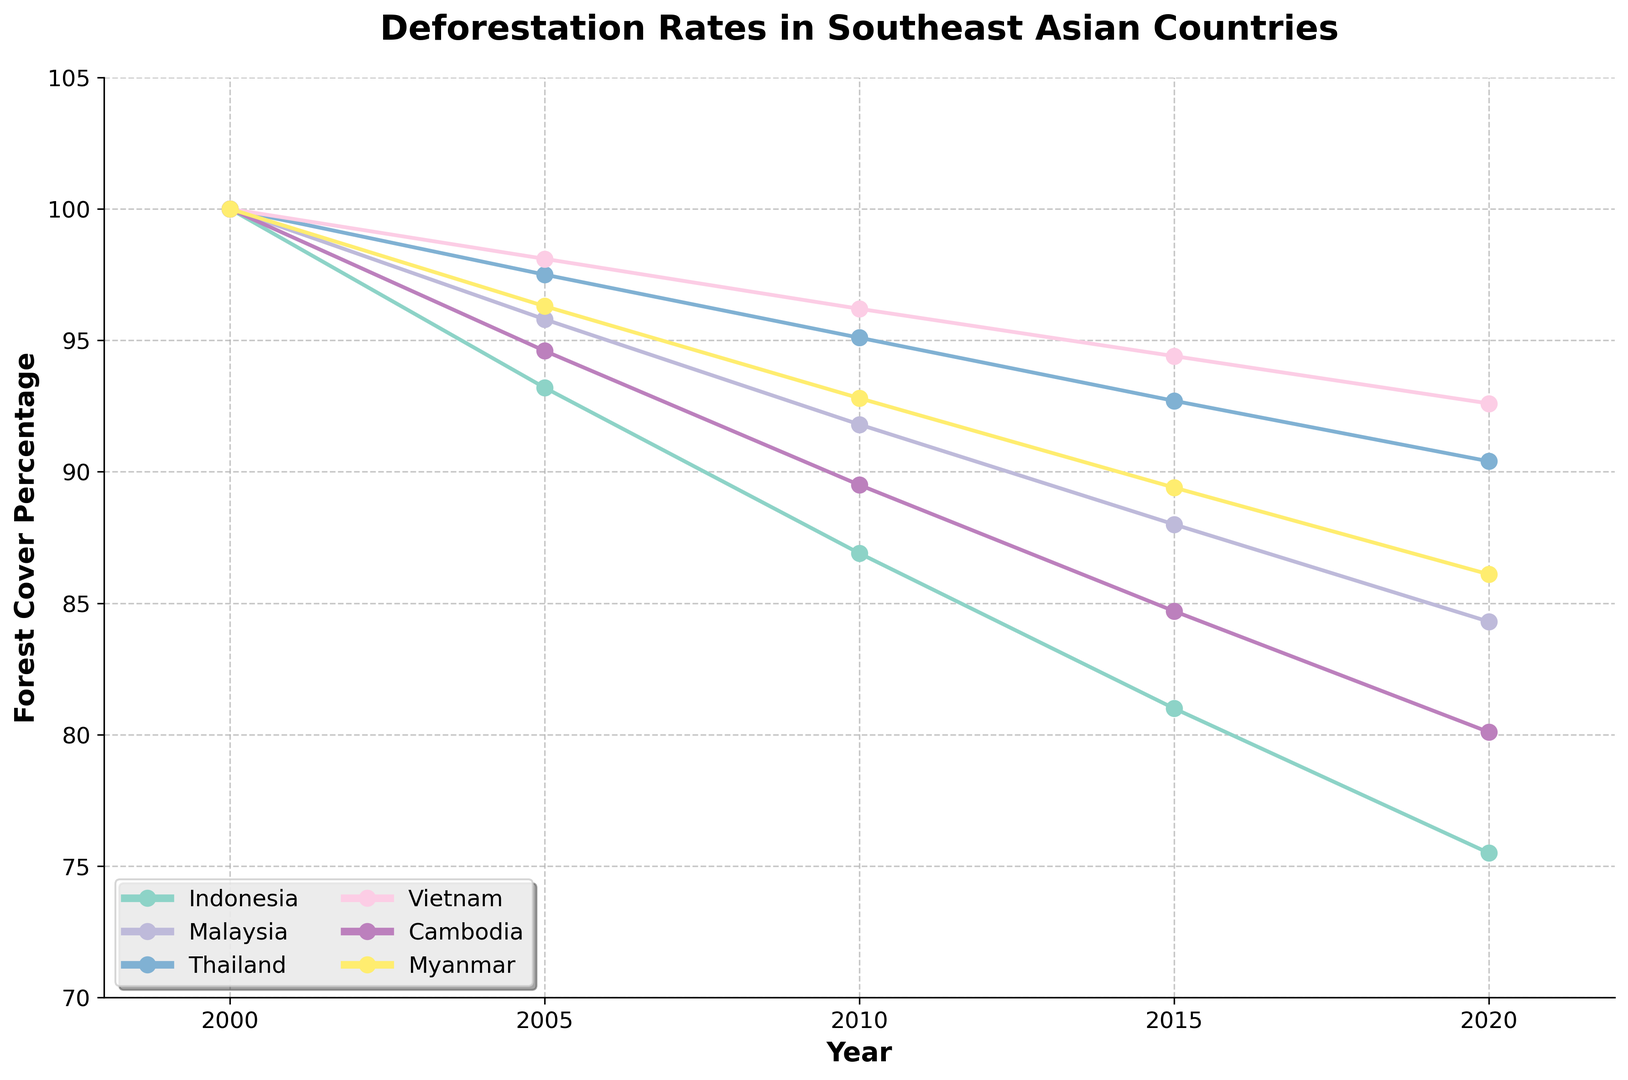What is the overall trend of forest cover percentage in Indonesia from 2000 to 2020? The plot shows a visible decline in the forest cover percentage for Indonesia over the years 2000 to 2020. The percentage starts at 100% in 2000 and decreases to around 75.5% by 2020.
Answer: Declining Which country had the highest forest cover percentage in 2020? By observing the endpoint of each country's line in the plot for the year 2020, Vietnam has the highest forest cover percentage around 92.6%.
Answer: Vietnam Compare the rate of deforestation between Malaysia and Cambodia from 2000 to 2020. Which country experienced a greater reduction in forest cover percentage? For Malaysia, the reduction is from 100% to 84.3%, a decrease of 15.7%. For Cambodia, the reduction is from 100% to 80.1%, a decrease of 19.9%. Cambodia experienced a greater reduction in forest cover percentage.
Answer: Cambodia Calculate the average forest cover percentage for Thailand over the years 2000 to 2020. The values for Thailand are 100%, 97.5%, 95.1%, 92.7%, and 90.4%. The average is calculated as (100 + 97.5 + 95.1 + 92.7 + 90.4) / 5 = 95.14%.
Answer: 95.14% Which country shows the most stable (least varying) forest cover percentage trend from 2000 to 2020? By visually comparing the curves, Vietnam shows the most stable trend, with the smallest reduction in forest cover over the 20 years, from 100% to 92.6%.
Answer: Vietnam In which period (2000-2005, 2005-2010, 2010-2015, or 2015-2020) did Myanmar experience the steepest decline in forest cover percentage? By looking at the steepness of the line segments, the decline from 2010 to 2015 is the most pronounced, where the forest cover percentage drops from 92.8% to 89.4%.
Answer: 2010-2015 What is the difference in forest cover percentage between Malaysia and Thailand in 2015? In 2015, the forest cover data shows Malaysia at 88.0% and Thailand at 92.7%. The difference is 92.7% - 88.0% = 4.7%.
Answer: 4.7% Based on the plot, which country seems to have the second fastest deforestation rate after Cambodia? Visually, Indonesia has a significantly steep decline after Cambodia. Indonesia's forest cover went from 100% to 75.5%, a considerable reduction over 20 years.
Answer: Indonesia What can be inferred about the deforestation policy effectiveness in Vietnam compared to other countries on this plot? Vietnam's forest cover percentage shows the smallest decline (7.4%) compared to other countries, suggesting relatively effective deforestation policies.
Answer: Effective Among the countries plotted, which one showed a forest cover percentage of just over 85% in 2020? The plot indicates Malaysia with a forest cover percentage slightly above 85% in 2020.
Answer: Malaysia 